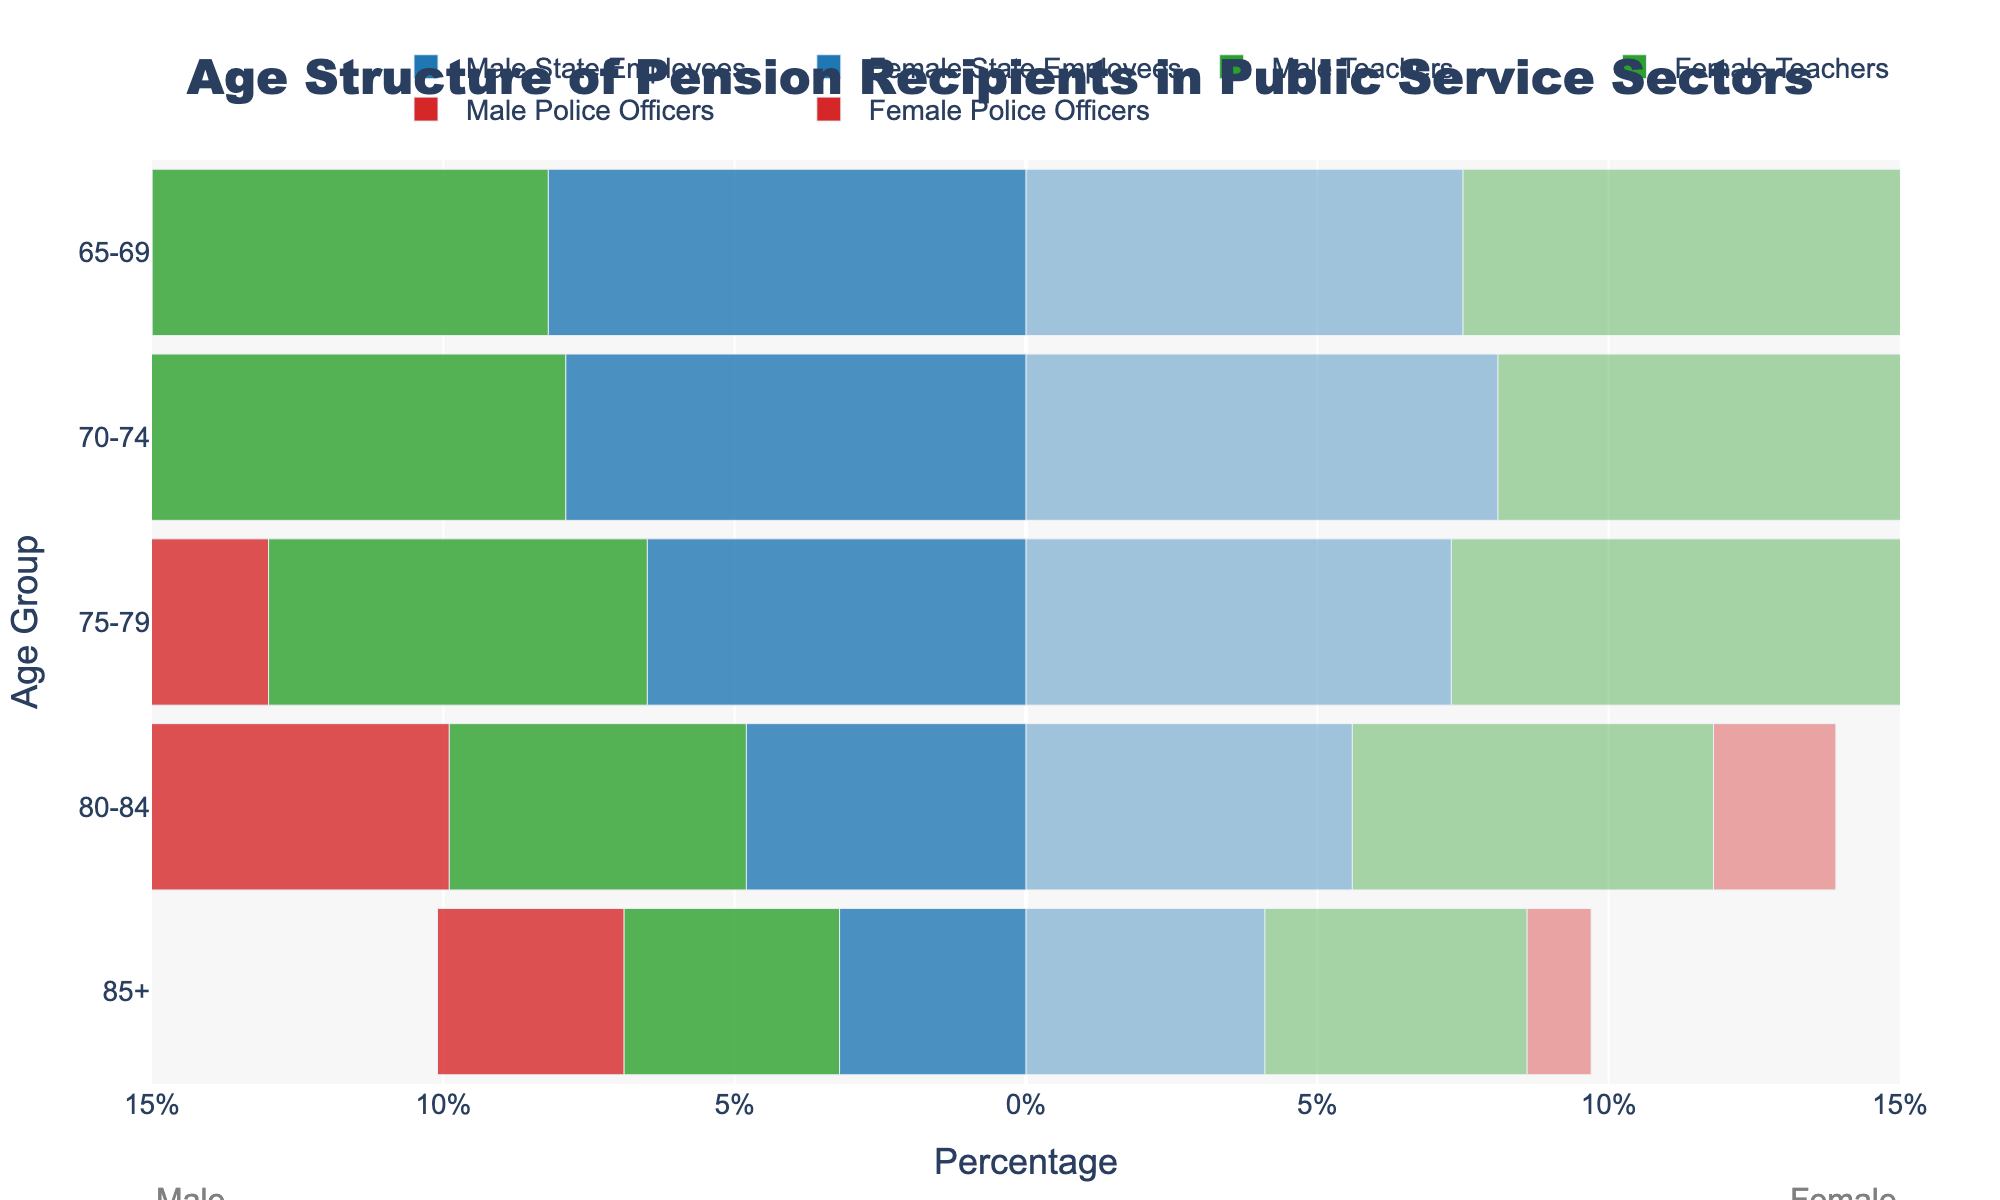What is the title of the figure? The title is typically placed at the top center of the figure. It describes the primary focus or content of the visualization.
Answer: Age Structure of Pension Recipients in Public Service Sectors What are the age groups shown on the y-axis? The y-axis represents the age groups, which are listed vertically. These age groups help categorize the data into different segments of the population. The age groups shown are: 65-69, 70-74, 75-79, 80-84, and 85+.
Answer: 65-69, 70-74, 75-79, 80-84, 85+ What percentage of Female Teachers are in the 75-79 age group? Locate the Female Teachers bar corresponding to the 75-79 age group on the right side of the plot and note the percentage value.
Answer: 7.9% What is the combined percentage of Male State Employees in the 70-74 and 75-79 age groups? First, identify the percentages for Male State Employees in the 70-74 (7.9%) and 75-79 (6.5%) age groups, then sum these values.
Answer: 7.9% + 6.5% = 14.4% In which age group do Female Police Officers and Male Police Officers have equal percentages? Compare the equal-length bars of Female Police Officers and Male Police Officers within different age groups until you find the pair. The bars are only equal in the 85+ age group.
Answer: 85+ Which category has the highest percentage of males in the 65-69 age group? Examine the bars for Male State Employees, Male Teachers, and Male Police Officers in the 65-69 age group and compare their lengths. Male Police Officers have the highest percentage.
Answer: Male Police Officers How does the percentage of Male Police Officers in the 80-84 age group compare to the percentage of Female Police Officers in the same group? Look at the lengths of the bars for Male Police Officers and Female Police Officers in the 80-84 age group. Male Police Officers have a higher percentage than Female Police Officers.
Answer: Higher What is the percentage difference between Male and Female Teachers in the 65-69 age group? Locate the percentages for Male Teachers (6.8%) and Female Teachers (9.1%) in the 65-69 age group, then subtract the smaller value from the larger value.
Answer: 9.1% - 6.8% = 2.3% How do the percentages of Male and Female State Employees in the 70-74 age group compare? Identify the percentages for Male State Employees and Female State Employees in the 70-74 age group. Notice that Female State Employees (8.1%) have a slightly higher percentage than Male State Employees (7.9%).
Answer: Female State Employees have a higher percentage Which gender has a higher percentage of pension recipients in the 75-79 age group among Teachers? Compare the percentages between Male and Female Teachers within the 75-79 age group. Female Teachers (7.9%) have a higher percentage than Male Teachers (6.5%).
Answer: Female Teachers 